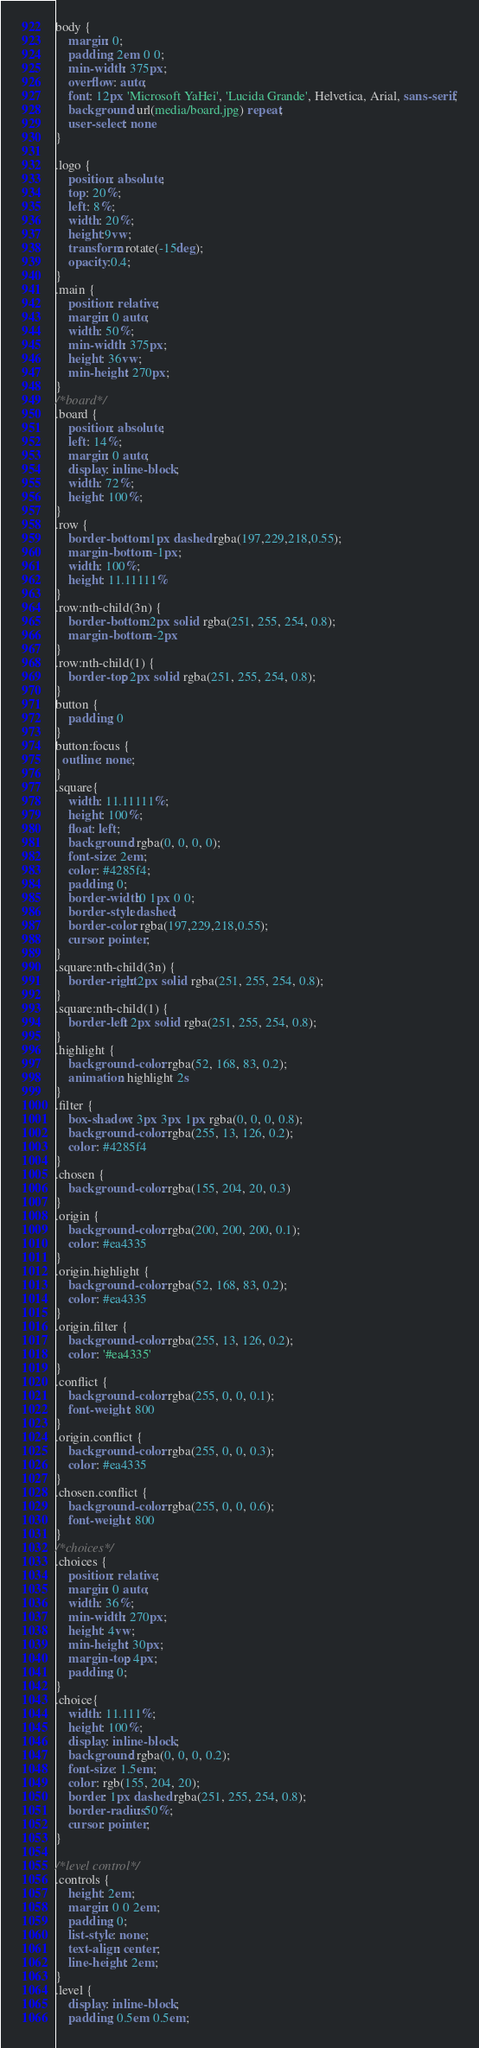<code> <loc_0><loc_0><loc_500><loc_500><_CSS_>body {
    margin: 0;
    padding: 2em 0 0;
    min-width: 375px;
    overflow: auto;
    font: 12px 'Microsoft YaHei', 'Lucida Grande', Helvetica, Arial, sans-serif;
    background: url(media/board.jpg) repeat;
    user-select: none
}

.logo {
    position: absolute;
    top: 20%;
    left: 8%;
    width: 20%;
    height:9vw;
    transform: rotate(-15deg);
    opacity:0.4;
}
.main {
    position: relative;
    margin: 0 auto;
    width: 50%;
    min-width: 375px;
    height: 36vw;
    min-height: 270px;
}
/*board*/
.board {
    position: absolute;
    left: 14%;
    margin: 0 auto;
    display: inline-block;
    width: 72%;
    height: 100%;
}
.row {
    border-bottom: 1px dashed rgba(197,229,218,0.55);
    margin-bottom: -1px;
    width: 100%;
    height: 11.11111%
}
.row:nth-child(3n) {
    border-bottom: 2px solid rgba(251, 255, 254, 0.8);
    margin-bottom: -2px
}
.row:nth-child(1) {
    border-top: 2px solid rgba(251, 255, 254, 0.8);
}
button {
    padding: 0
}
button:focus {
  outline: none;
}
.square{
    width: 11.11111%;
    height: 100%;
    float: left;
    background: rgba(0, 0, 0, 0);
    font-size: 2em;
    color: #4285f4;
    padding: 0;
    border-width:0 1px 0 0;
    border-style: dashed;
    border-color: rgba(197,229,218,0.55);
    cursor: pointer;
}
.square:nth-child(3n) {
    border-right: 2px solid rgba(251, 255, 254, 0.8);
}
.square:nth-child(1) {
    border-left: 2px solid rgba(251, 255, 254, 0.8);
}
.highlight {
    background-color: rgba(52, 168, 83, 0.2);
    animation: highlight 2s
}
.filter {
    box-shadow: 3px 3px 1px rgba(0, 0, 0, 0.8);
    background-color: rgba(255, 13, 126, 0.2);
    color: #4285f4
}
.chosen {
    background-color: rgba(155, 204, 20, 0.3)
}
.origin {
    background-color: rgba(200, 200, 200, 0.1);
    color: #ea4335
}
.origin.highlight {
    background-color: rgba(52, 168, 83, 0.2);
    color: #ea4335
}
.origin.filter {
    background-color: rgba(255, 13, 126, 0.2);
    color: '#ea4335'
}
.conflict {
    background-color: rgba(255, 0, 0, 0.1);
    font-weight: 800
}
.origin.conflict {
    background-color: rgba(255, 0, 0, 0.3);
    color: #ea4335
}
.chosen.conflict {
    background-color: rgba(255, 0, 0, 0.6);
    font-weight: 800
}
/*choices*/
.choices {
    position: relative;
    margin: 0 auto;
    width: 36%;
    min-width: 270px;
    height: 4vw;
    min-height: 30px;
    margin-top: 4px;
    padding: 0;
}
.choice{
    width: 11.111%;
    height: 100%;
    display: inline-block;
    background: rgba(0, 0, 0, 0.2);
    font-size: 1.5em;
    color: rgb(155, 204, 20);
    border: 1px dashed rgba(251, 255, 254, 0.8);
    border-radius: 50%;
    cursor: pointer;
}

/*level control*/
.controls {
    height: 2em;
    margin: 0 0 2em;
    padding: 0;
    list-style: none;
    text-align: center;
    line-height: 2em;
}
.level {
    display: inline-block;
    padding: 0.5em 0.5em;</code> 